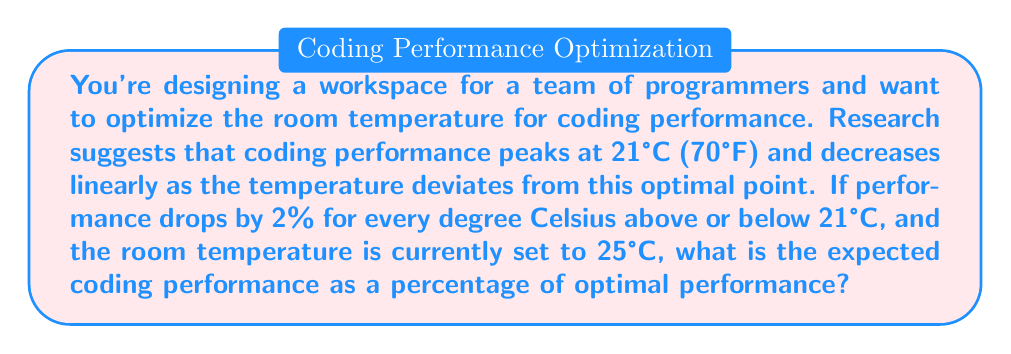Could you help me with this problem? To solve this problem, we need to follow these steps:

1. Determine the temperature difference from the optimal point:
   $\Delta T = |25°C - 21°C| = 4°C$

2. Calculate the performance drop:
   Performance drop = 2% per °C × 4°C = 8%

3. Calculate the expected performance as a percentage of optimal:
   Expected performance = 100% - 8% = 92%

Let's formalize this with a function:

Let $P(T)$ be the performance function, where $T$ is the temperature in °C.
$$P(T) = \begin{cases}
100\% - 2\%|T - 21| & \text{if } |T - 21| \leq 50 \\
0\% & \text{otherwise}
\end{cases}$$

This function assumes that performance drops to 0% if the temperature deviates by more than 50°C from the optimal point, which is a reasonable assumption for extreme temperatures.

For our case:
$$P(25) = 100\% - 2\%|25 - 21| = 100\% - 2\%(4) = 100\% - 8\% = 92\%$$

Therefore, at 25°C, the expected coding performance is 92% of the optimal performance.
Answer: 92% 